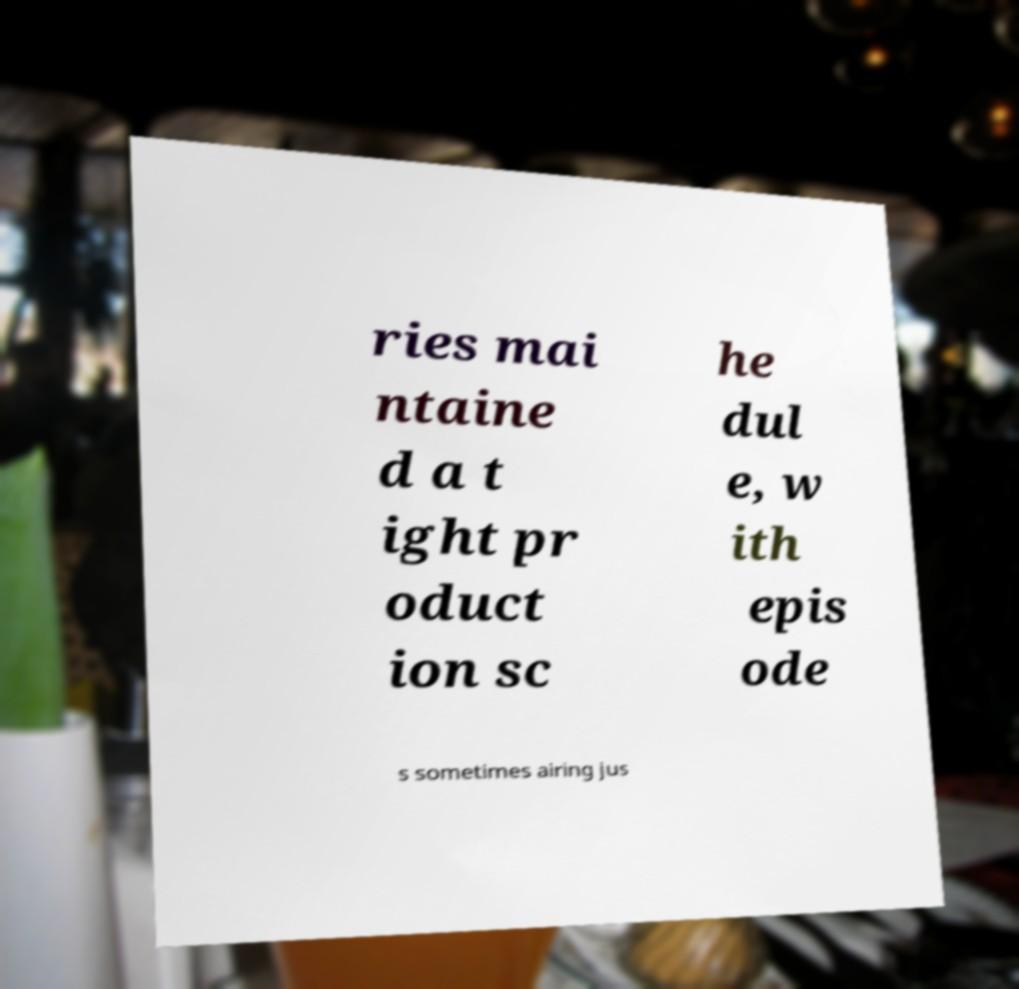Can you read and provide the text displayed in the image?This photo seems to have some interesting text. Can you extract and type it out for me? ries mai ntaine d a t ight pr oduct ion sc he dul e, w ith epis ode s sometimes airing jus 